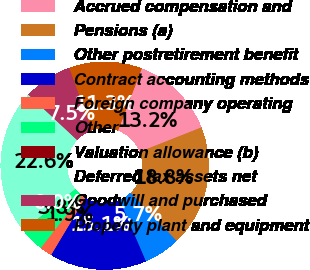<chart> <loc_0><loc_0><loc_500><loc_500><pie_chart><fcel>Accrued compensation and<fcel>Pensions (a)<fcel>Other postretirement benefit<fcel>Contract accounting methods<fcel>Foreign company operating<fcel>Other<fcel>Valuation allowance (b)<fcel>Deferred tax assets net<fcel>Goodwill and purchased<fcel>Property plant and equipment<nl><fcel>13.2%<fcel>18.85%<fcel>5.67%<fcel>15.08%<fcel>1.91%<fcel>3.79%<fcel>0.02%<fcel>22.61%<fcel>7.55%<fcel>11.32%<nl></chart> 